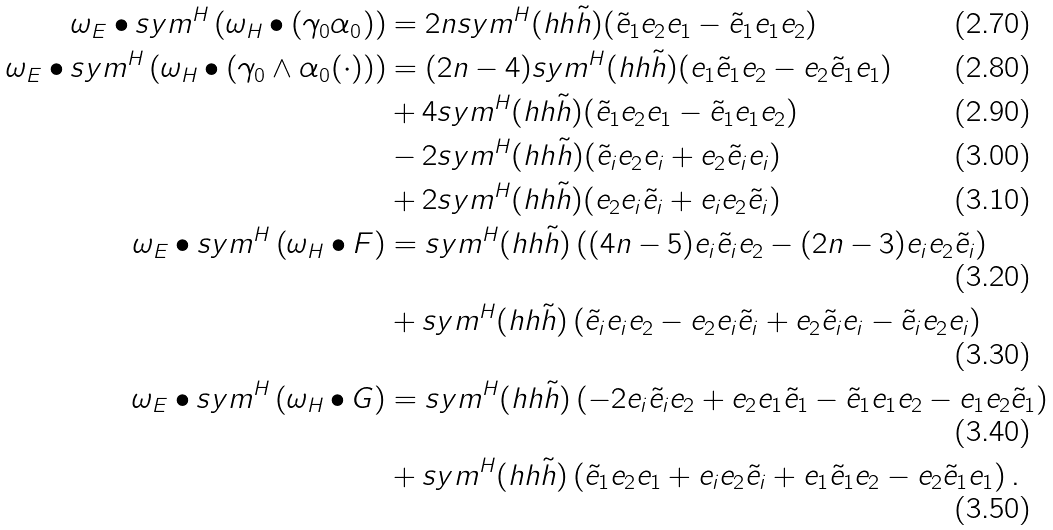Convert formula to latex. <formula><loc_0><loc_0><loc_500><loc_500>\omega _ { E } \bullet s y m ^ { H } \left ( \omega _ { H } \bullet ( \gamma _ { 0 } \alpha _ { 0 } ) \right ) & = 2 n s y m ^ { H } ( h h \tilde { h } ) ( \tilde { e } _ { 1 } e _ { 2 } e _ { 1 } - \tilde { e } _ { 1 } e _ { 1 } e _ { 2 } ) \\ \omega _ { E } \bullet s y m ^ { H } \left ( \omega _ { H } \bullet ( \gamma _ { 0 } \wedge \alpha _ { 0 } ( \cdot ) ) \right ) & = ( 2 n - 4 ) s y m ^ { H } ( h h \tilde { h } ) ( e _ { 1 } \tilde { e } _ { 1 } e _ { 2 } - e _ { 2 } \tilde { e } _ { 1 } e _ { 1 } ) \\ & + 4 s y m ^ { H } ( h h \tilde { h } ) ( \tilde { e } _ { 1 } e _ { 2 } e _ { 1 } - \tilde { e } _ { 1 } e _ { 1 } e _ { 2 } ) \\ & - 2 s y m ^ { H } ( h h \tilde { h } ) ( \tilde { e } _ { i } e _ { 2 } e _ { i } + e _ { 2 } \tilde { e } _ { i } e _ { i } ) \\ & + 2 s y m ^ { H } ( h h \tilde { h } ) ( e _ { 2 } e _ { i } \tilde { e } _ { i } + e _ { i } e _ { 2 } \tilde { e } _ { i } ) \\ \omega _ { E } \bullet s y m ^ { H } \left ( \omega _ { H } \bullet F \right ) & = s y m ^ { H } ( h h \tilde { h } ) \left ( ( 4 n - 5 ) e _ { i } \tilde { e } _ { i } e _ { 2 } - ( 2 n - 3 ) e _ { i } e _ { 2 } \tilde { e } _ { i } \right ) \\ & + s y m ^ { H } ( h h \tilde { h } ) \left ( \tilde { e } _ { i } e _ { i } e _ { 2 } - e _ { 2 } e _ { i } \tilde { e } _ { i } + e _ { 2 } \tilde { e } _ { i } e _ { i } - \tilde { e } _ { i } e _ { 2 } e _ { i } \right ) \\ \omega _ { E } \bullet s y m ^ { H } \left ( \omega _ { H } \bullet G \right ) & = s y m ^ { H } ( h h \tilde { h } ) \left ( - 2 e _ { i } \tilde { e } _ { i } e _ { 2 } + e _ { 2 } e _ { 1 } \tilde { e } _ { 1 } - \tilde { e } _ { 1 } e _ { 1 } e _ { 2 } - e _ { 1 } e _ { 2 } \tilde { e } _ { 1 } \right ) \\ & + s y m ^ { H } ( h h \tilde { h } ) \left ( \tilde { e } _ { 1 } e _ { 2 } e _ { 1 } + e _ { i } e _ { 2 } \tilde { e } _ { i } + e _ { 1 } \tilde { e } _ { 1 } e _ { 2 } - e _ { 2 } \tilde { e } _ { 1 } e _ { 1 } \right ) .</formula> 